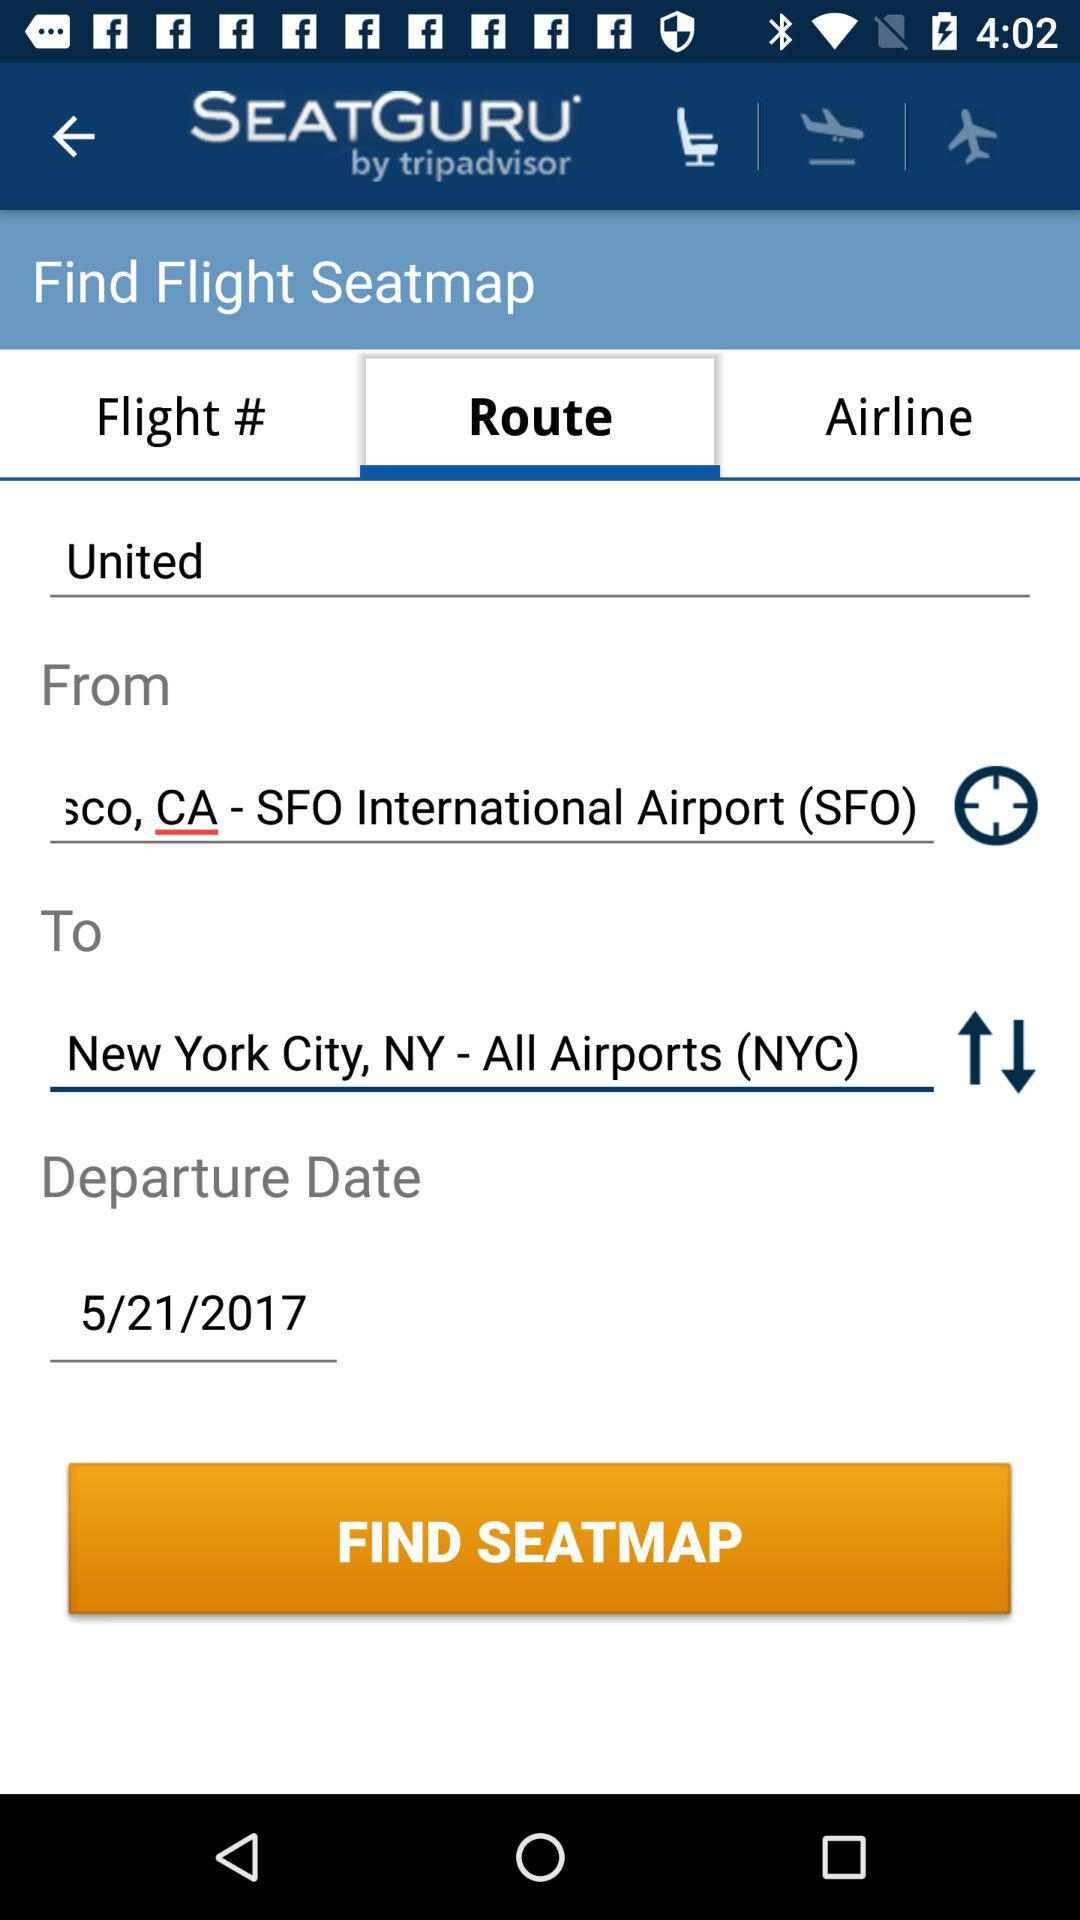What is the name of the application? The name of the application is "SEATGURU". 